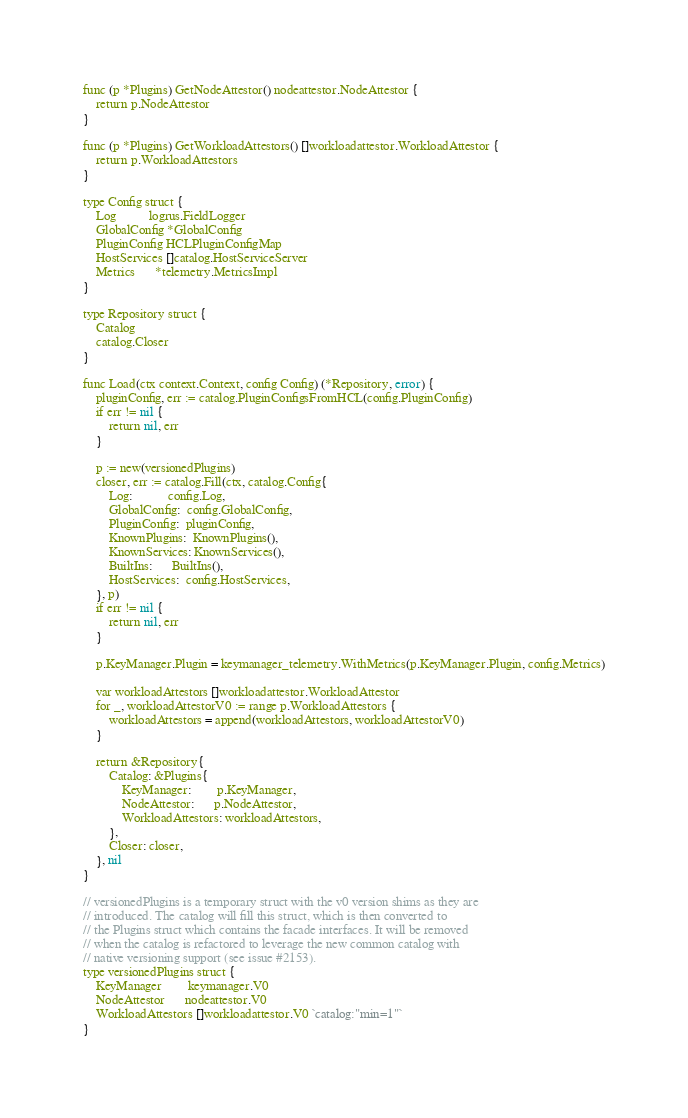<code> <loc_0><loc_0><loc_500><loc_500><_Go_>
func (p *Plugins) GetNodeAttestor() nodeattestor.NodeAttestor {
	return p.NodeAttestor
}

func (p *Plugins) GetWorkloadAttestors() []workloadattestor.WorkloadAttestor {
	return p.WorkloadAttestors
}

type Config struct {
	Log          logrus.FieldLogger
	GlobalConfig *GlobalConfig
	PluginConfig HCLPluginConfigMap
	HostServices []catalog.HostServiceServer
	Metrics      *telemetry.MetricsImpl
}

type Repository struct {
	Catalog
	catalog.Closer
}

func Load(ctx context.Context, config Config) (*Repository, error) {
	pluginConfig, err := catalog.PluginConfigsFromHCL(config.PluginConfig)
	if err != nil {
		return nil, err
	}

	p := new(versionedPlugins)
	closer, err := catalog.Fill(ctx, catalog.Config{
		Log:           config.Log,
		GlobalConfig:  config.GlobalConfig,
		PluginConfig:  pluginConfig,
		KnownPlugins:  KnownPlugins(),
		KnownServices: KnownServices(),
		BuiltIns:      BuiltIns(),
		HostServices:  config.HostServices,
	}, p)
	if err != nil {
		return nil, err
	}

	p.KeyManager.Plugin = keymanager_telemetry.WithMetrics(p.KeyManager.Plugin, config.Metrics)

	var workloadAttestors []workloadattestor.WorkloadAttestor
	for _, workloadAttestorV0 := range p.WorkloadAttestors {
		workloadAttestors = append(workloadAttestors, workloadAttestorV0)
	}

	return &Repository{
		Catalog: &Plugins{
			KeyManager:        p.KeyManager,
			NodeAttestor:      p.NodeAttestor,
			WorkloadAttestors: workloadAttestors,
		},
		Closer: closer,
	}, nil
}

// versionedPlugins is a temporary struct with the v0 version shims as they are
// introduced. The catalog will fill this struct, which is then converted to
// the Plugins struct which contains the facade interfaces. It will be removed
// when the catalog is refactored to leverage the new common catalog with
// native versioning support (see issue #2153).
type versionedPlugins struct {
	KeyManager        keymanager.V0
	NodeAttestor      nodeattestor.V0
	WorkloadAttestors []workloadattestor.V0 `catalog:"min=1"`
}
</code> 